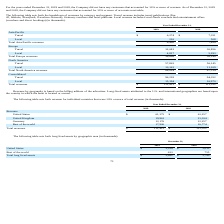According to Travelzoo's financial document, What is revenue by geography based on? billing address of the advertiser. The document states: "Revenue by geography is based on the billing address of the advertiser. Long-lived assets attributed to the U.S. and international geographies are bas..." Also, What is the total Asia Pacific revenues in 2019 and 2018 respectively? The document shows two values: 6,490 and 7,859 (in thousands). From the document: "Total Asia Pacific revenues 6,490 7,859 Total Asia Pacific revenues 6,490 7,859..." Also, What is the total Europe revenues in 2019 and 2018 respectively? The document shows two values: 36,898 and 36,149 (in thousands). From the document: "Total Europe revenues 36,898 36,149 Total Europe revenues 36,898 36,149..." Also, can you calculate: What is the change in total revenues between 2018 and 2019? Based on the calculation: 111,412-111,322, the result is 90 (in thousands). This is based on the information: "Total revenues $ 111,412 $ 111,322 Total revenues $ 111,412 $ 111,322..." The key data points involved are: 111,322, 111,412. Also, can you calculate: What is the average of the total Asia Pacific revenues in 2018 and 2019? To answer this question, I need to perform calculations using the financial data. The calculation is: (6,490+ 7,859)/2, which equals 7174.5 (in thousands). This is based on the information: "Total Asia Pacific revenues 6,490 7,859 Total Asia Pacific revenues 6,490 7,859..." The key data points involved are: 6,490, 7,859. Also, In 2019, how many geographic regions have total revenues of more than $20,000 thousand? Counting the relevant items in the document: Europe ,  North America, I find 2 instances. The key data points involved are: Europe, North America. 